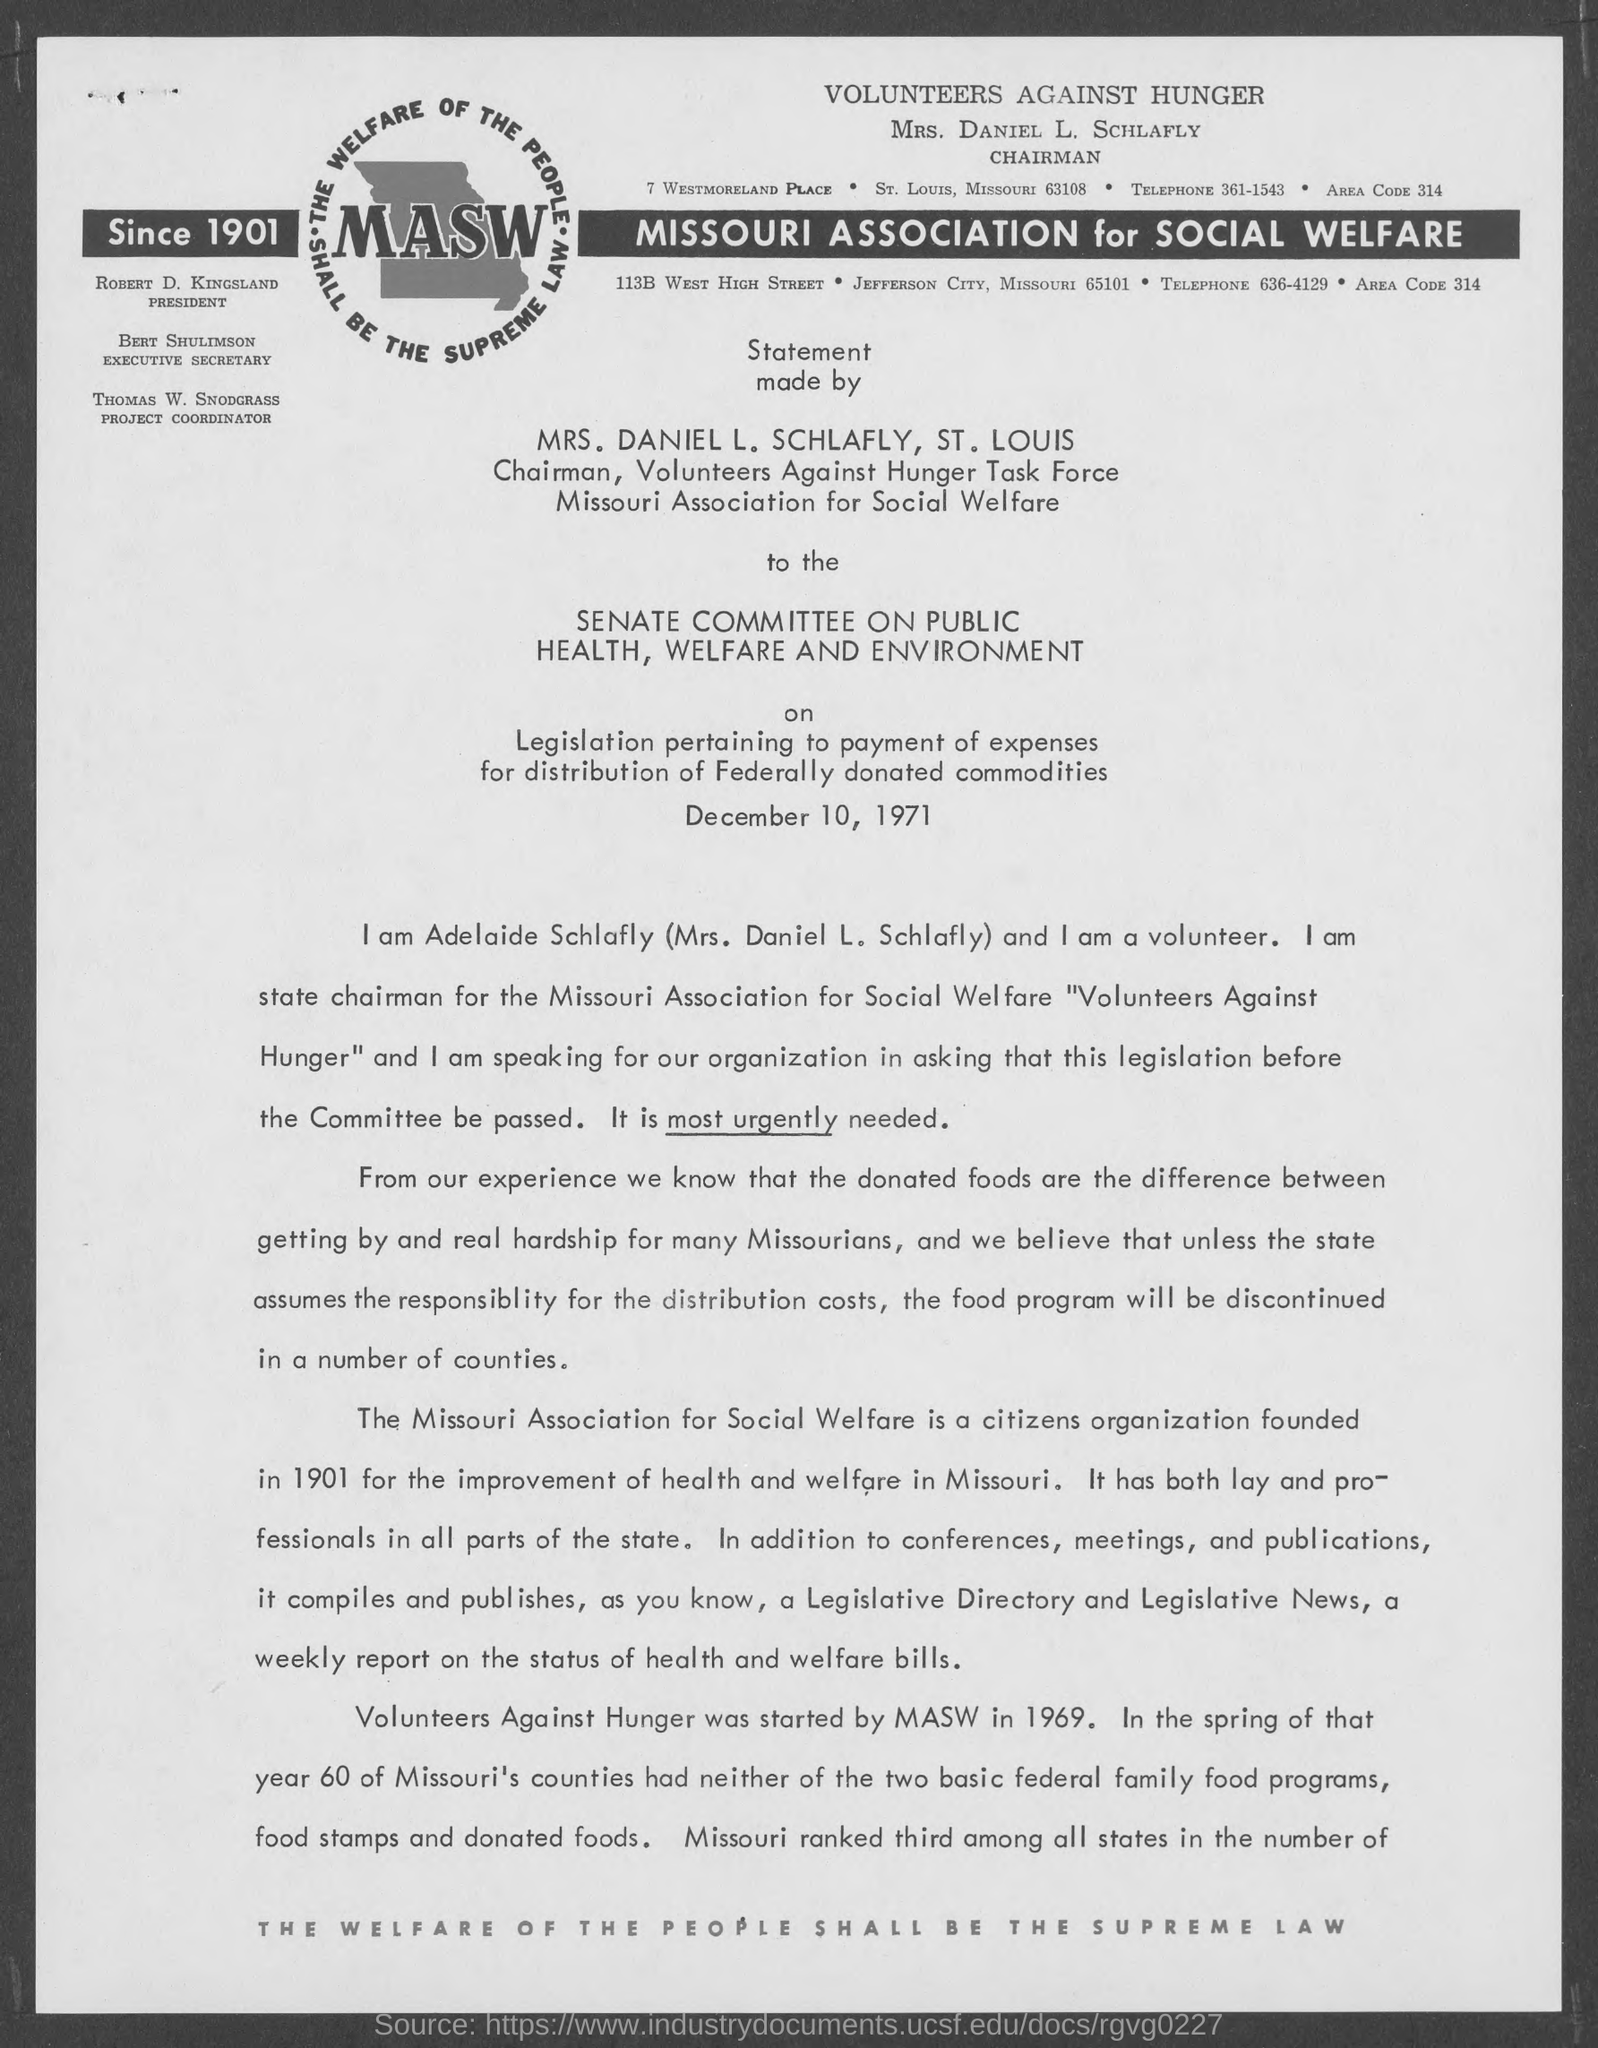Highlight a few significant elements in this photo. The telephone number mentioned in the given page is 361-1543. The project coordinator mentioned in the given page is Thomas W. Snodgrass. The full form of "Masw" as mentioned in the given form is "Missouri Association for Social Welfare". The heading on the given page is 'Volunteers Against Hunger'. The area code mentioned in the given form is 314.. 